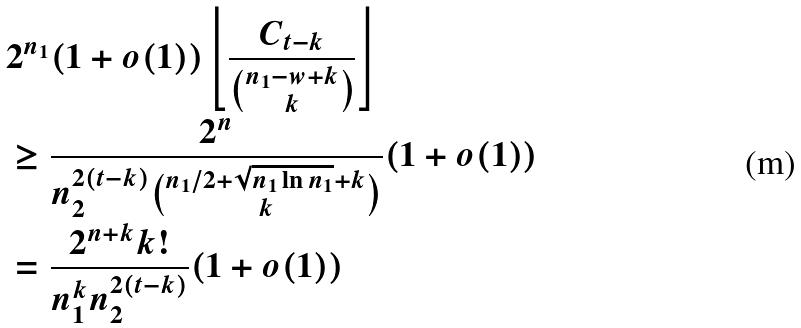Convert formula to latex. <formula><loc_0><loc_0><loc_500><loc_500>& 2 ^ { n _ { 1 } } ( 1 + o ( 1 ) ) \left \lfloor \frac { C _ { t - k } } { \binom { n _ { 1 } - w + k } { k } } \right \rfloor \\ & \geq \frac { 2 ^ { n } } { n _ { 2 } ^ { 2 ( t - k ) } \binom { n _ { 1 } / 2 + \sqrt { n _ { 1 } \ln n _ { 1 } } + k } { k } } ( 1 + o ( 1 ) ) \\ & = \frac { 2 ^ { n + k } k ! } { n _ { 1 } ^ { k } n _ { 2 } ^ { 2 ( t - k ) } } ( 1 + o ( 1 ) )</formula> 